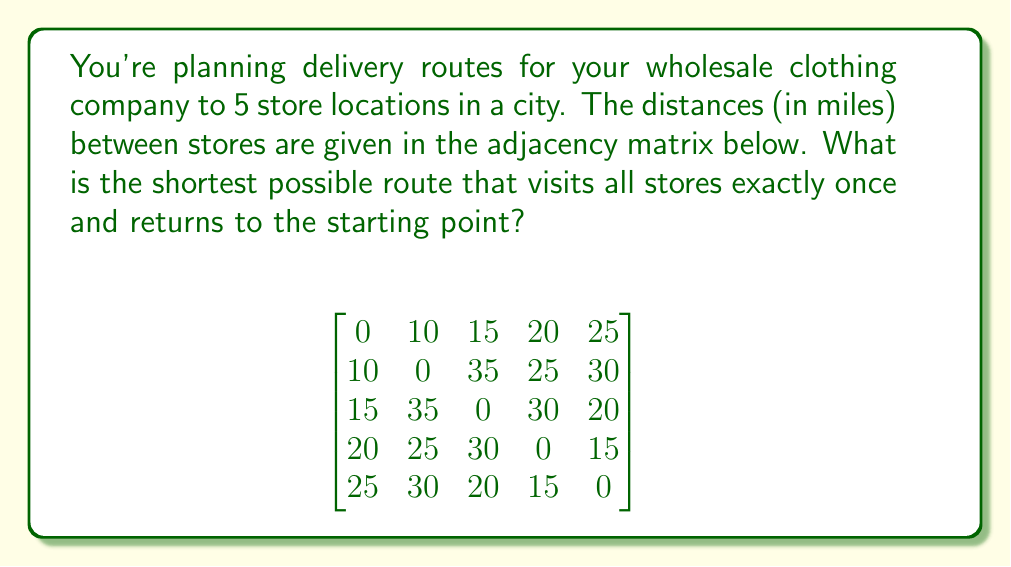Teach me how to tackle this problem. To solve this problem, we'll use the Held-Karp algorithm, which is an exact method for solving the Traveling Salesman Problem (TSP):

1) First, we'll calculate the minimum cost for all subsets of size 2:
   $C(\{1,2\}, 2) = 10$
   $C(\{1,3\}, 3) = 15$
   $C(\{1,4\}, 4) = 20$
   $C(\{1,5\}, 5) = 25$

2) For subsets of size 3:
   $C(\{1,2,3\}, 2) = \min(C(\{1,3\}, 3) + 35, C(\{1,2\}, 2) + 15) = 30$
   $C(\{1,2,3\}, 3) = \min(C(\{1,2\}, 2) + 35, C(\{1,3\}, 3) + 10) = 25$
   ...

3) Continue this process for subsets of size 4 and 5.

4) For the final step, calculate:
   $\min_{j \neq 1} (C(\{1,2,3,4,5\}, j) + d_{j1})$

5) After completing all calculations, we find that the minimum cost is 95 miles.

6) To reconstruct the path, we backtrack through our calculations:
   1 → 3 → 5 → 4 → 2 → 1

Therefore, the optimal route is: Store 1 → Store 3 → Store 5 → Store 4 → Store 2 → Store 1, with a total distance of 95 miles.
Answer: 95 miles 